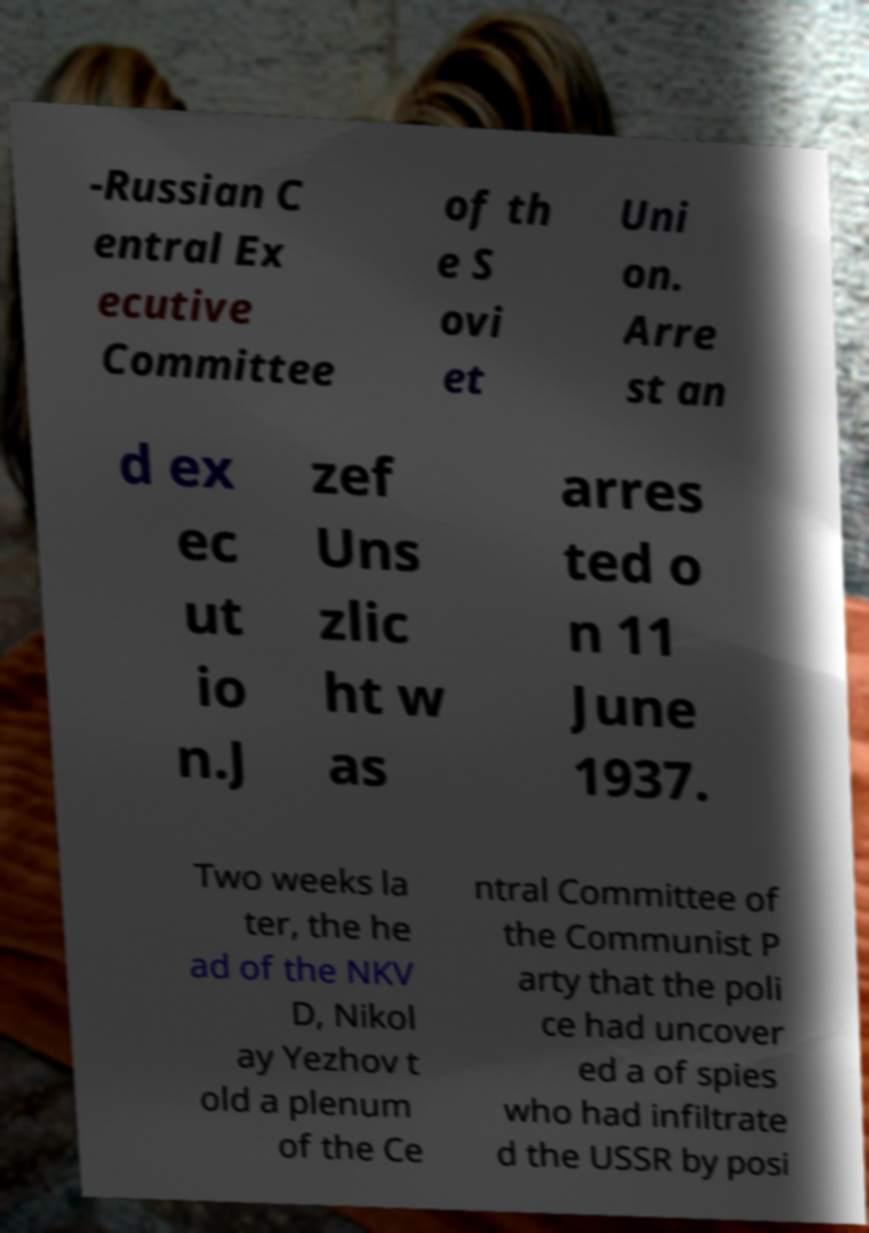I need the written content from this picture converted into text. Can you do that? -Russian C entral Ex ecutive Committee of th e S ovi et Uni on. Arre st an d ex ec ut io n.J zef Uns zlic ht w as arres ted o n 11 June 1937. Two weeks la ter, the he ad of the NKV D, Nikol ay Yezhov t old a plenum of the Ce ntral Committee of the Communist P arty that the poli ce had uncover ed a of spies who had infiltrate d the USSR by posi 